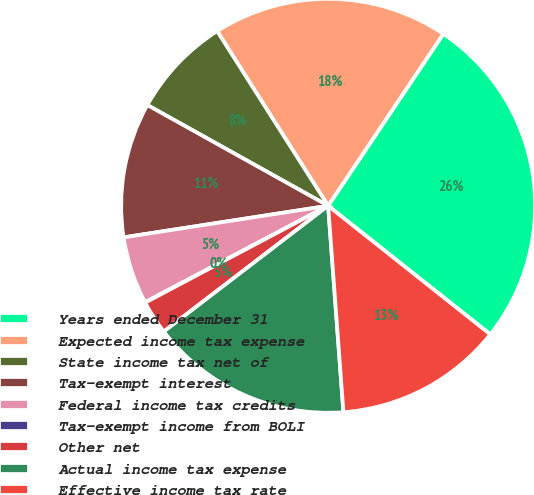Convert chart. <chart><loc_0><loc_0><loc_500><loc_500><pie_chart><fcel>Years ended December 31<fcel>Expected income tax expense<fcel>State income tax net of<fcel>Tax-exempt interest<fcel>Federal income tax credits<fcel>Tax-exempt income from BOLI<fcel>Other net<fcel>Actual income tax expense<fcel>Effective income tax rate<nl><fcel>26.28%<fcel>18.4%<fcel>7.9%<fcel>10.53%<fcel>5.28%<fcel>0.03%<fcel>2.65%<fcel>15.78%<fcel>13.15%<nl></chart> 